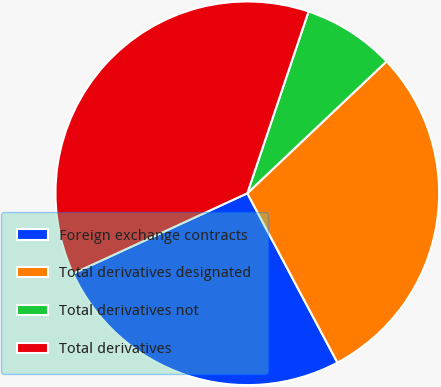Convert chart to OTSL. <chart><loc_0><loc_0><loc_500><loc_500><pie_chart><fcel>Foreign exchange contracts<fcel>Total derivatives designated<fcel>Total derivatives not<fcel>Total derivatives<nl><fcel>25.91%<fcel>29.28%<fcel>7.76%<fcel>37.04%<nl></chart> 